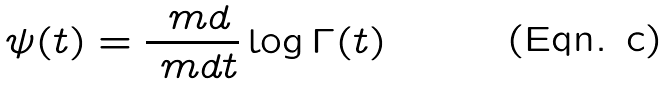<formula> <loc_0><loc_0><loc_500><loc_500>\psi ( t ) = \frac { \ m d } { \ m d t } \log \Gamma ( t )</formula> 